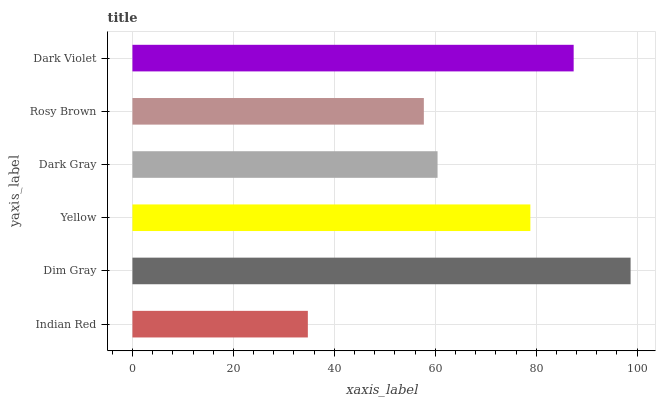Is Indian Red the minimum?
Answer yes or no. Yes. Is Dim Gray the maximum?
Answer yes or no. Yes. Is Yellow the minimum?
Answer yes or no. No. Is Yellow the maximum?
Answer yes or no. No. Is Dim Gray greater than Yellow?
Answer yes or no. Yes. Is Yellow less than Dim Gray?
Answer yes or no. Yes. Is Yellow greater than Dim Gray?
Answer yes or no. No. Is Dim Gray less than Yellow?
Answer yes or no. No. Is Yellow the high median?
Answer yes or no. Yes. Is Dark Gray the low median?
Answer yes or no. Yes. Is Rosy Brown the high median?
Answer yes or no. No. Is Indian Red the low median?
Answer yes or no. No. 